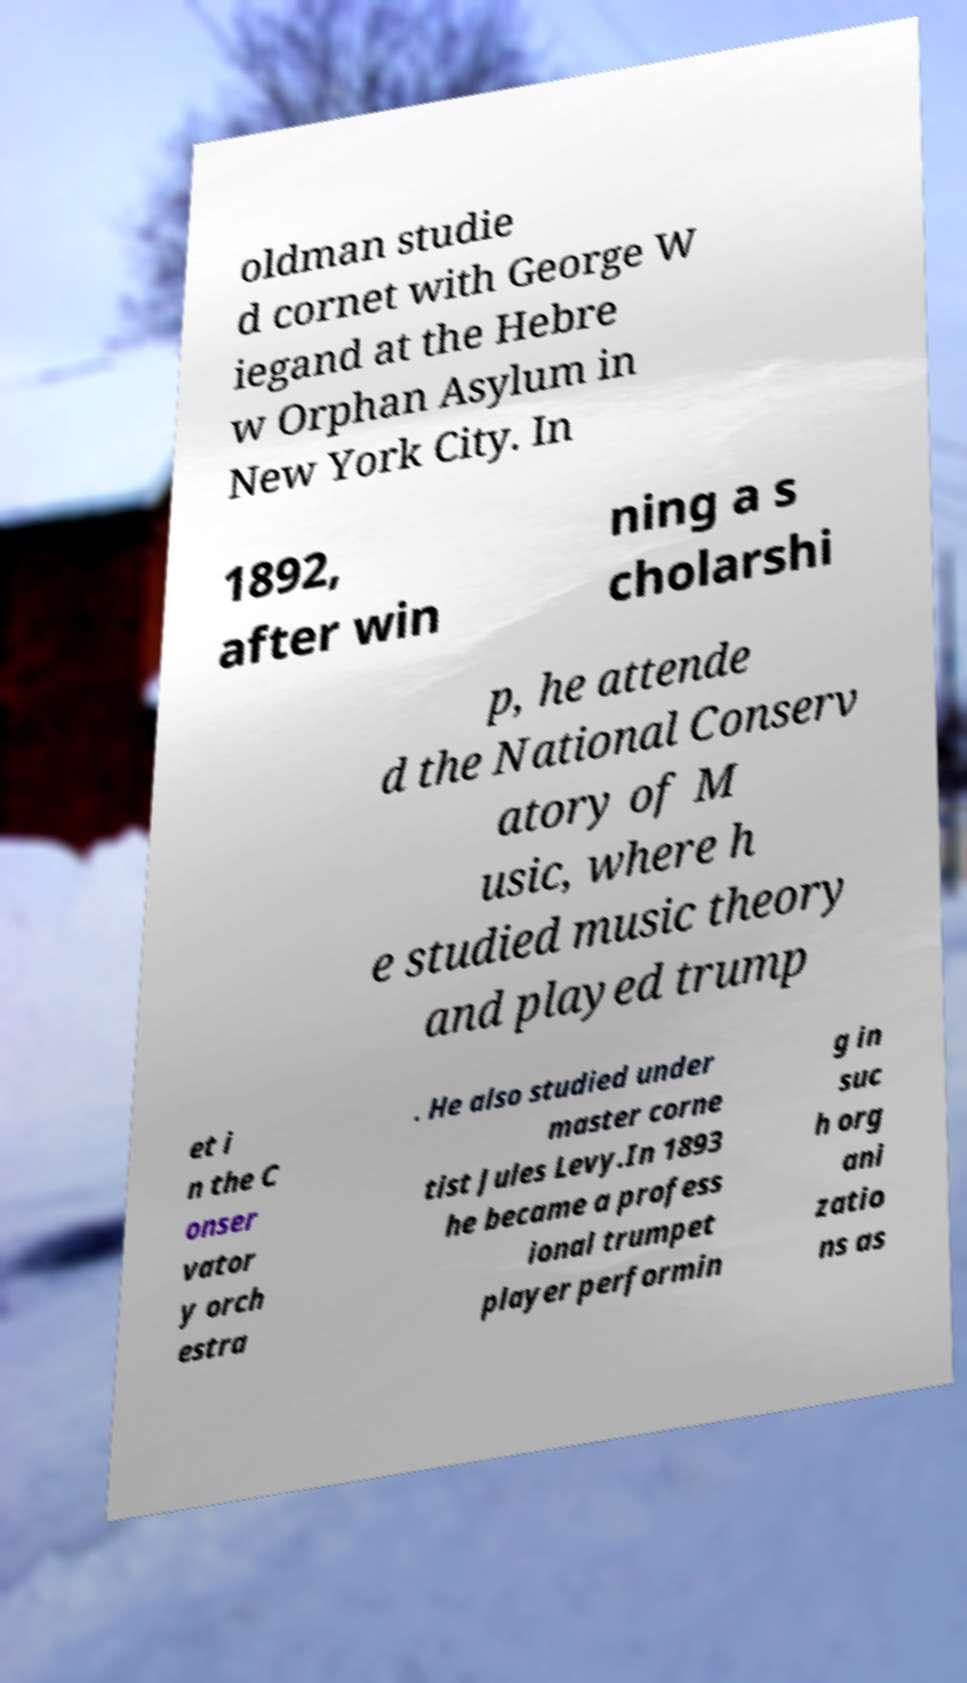Could you extract and type out the text from this image? oldman studie d cornet with George W iegand at the Hebre w Orphan Asylum in New York City. In 1892, after win ning a s cholarshi p, he attende d the National Conserv atory of M usic, where h e studied music theory and played trump et i n the C onser vator y orch estra . He also studied under master corne tist Jules Levy.In 1893 he became a profess ional trumpet player performin g in suc h org ani zatio ns as 